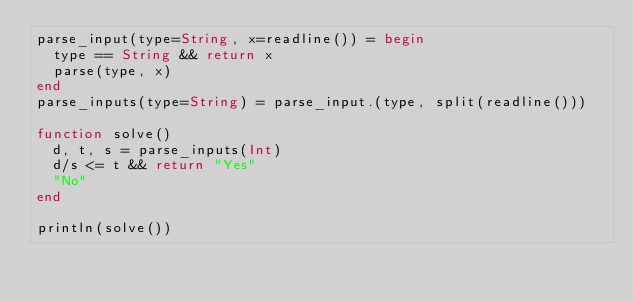Convert code to text. <code><loc_0><loc_0><loc_500><loc_500><_Julia_>parse_input(type=String, x=readline()) = begin
  type == String && return x
  parse(type, x)
end
parse_inputs(type=String) = parse_input.(type, split(readline()))

function solve()
  d, t, s = parse_inputs(Int)
  d/s <= t && return "Yes"
  "No"
end

println(solve())
</code> 